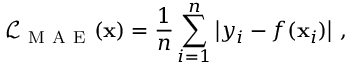<formula> <loc_0><loc_0><loc_500><loc_500>\mathcal { L } _ { M A E } ( x ) = \frac { 1 } { n } \sum _ { i = 1 } ^ { n } \left | y _ { i } - f ( x _ { i } ) \right | \, ,</formula> 